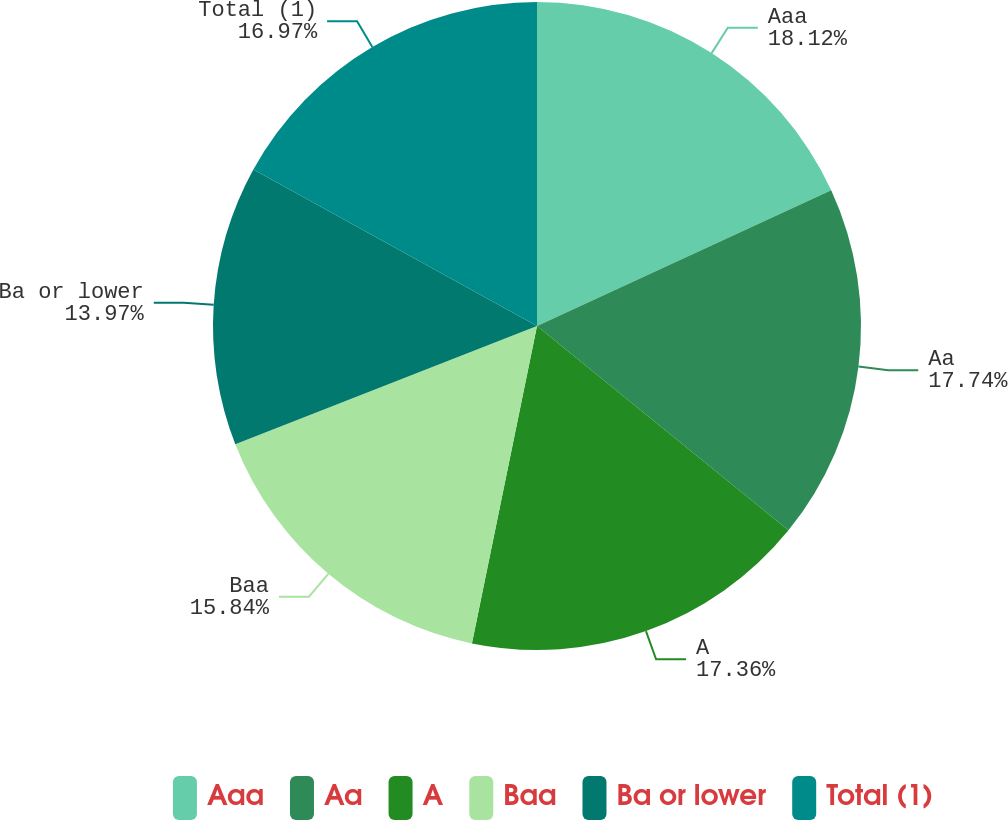Convert chart to OTSL. <chart><loc_0><loc_0><loc_500><loc_500><pie_chart><fcel>Aaa<fcel>Aa<fcel>A<fcel>Baa<fcel>Ba or lower<fcel>Total (1)<nl><fcel>18.12%<fcel>17.74%<fcel>17.36%<fcel>15.84%<fcel>13.97%<fcel>16.97%<nl></chart> 